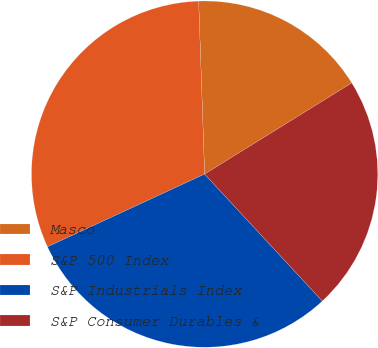<chart> <loc_0><loc_0><loc_500><loc_500><pie_chart><fcel>Masco<fcel>S&P 500 Index<fcel>S&P Industrials Index<fcel>S&P Consumer Durables &<nl><fcel>16.72%<fcel>31.35%<fcel>30.0%<fcel>21.93%<nl></chart> 